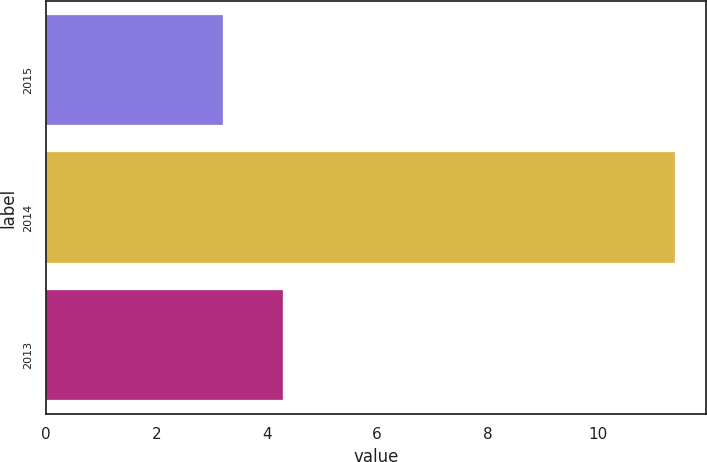<chart> <loc_0><loc_0><loc_500><loc_500><bar_chart><fcel>2015<fcel>2014<fcel>2013<nl><fcel>3.2<fcel>11.4<fcel>4.3<nl></chart> 